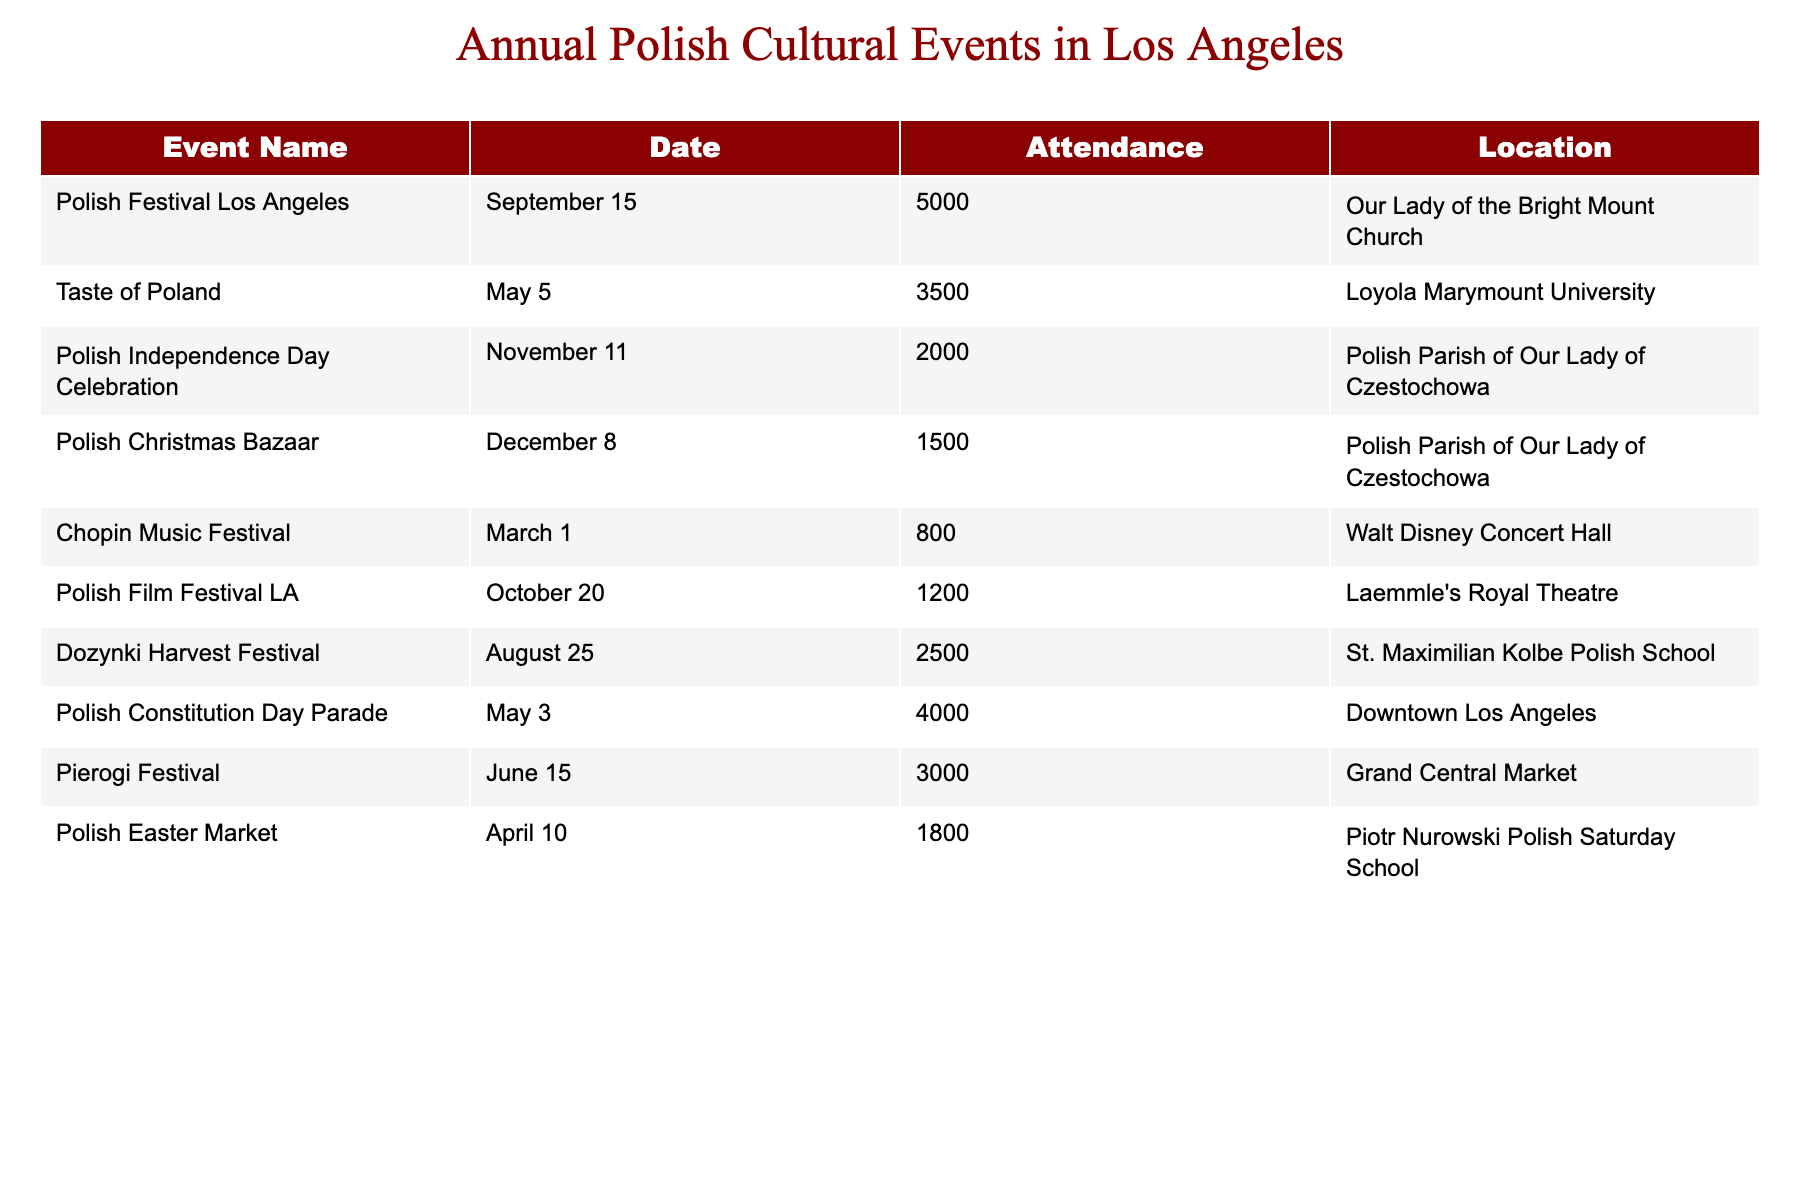What is the highest attendance figure recorded for any event? The highest attendance figure can be found by comparing the values in the Attendance column. Upon reviewing, the attendance for the Polish Festival Los Angeles is 5000, which is greater than all other provided figures.
Answer: 5000 Which event took place in December? The only event listed in December is the Polish Christmas Bazaar, which is shown in the table with its corresponding date.
Answer: Polish Christmas Bazaar What is the average attendance of the festivals held in May? The festivals held in May are the Taste of Poland with 3500 attendees and the Polish Constitution Day Parade with 4000. Adding these figures gives 3500 + 4000 = 7500. To find the average, we divide by the number of events (2): 7500 / 2 = 3750.
Answer: 3750 How many events had an attendance of 3000 or more? We can count the events listed with attendance figures of 3000 or more. These are the Polish Festival Los Angeles (5000), Taste of Poland (3500), Polish Constitution Day Parade (4000), Dozynki Harvest Festival (2500), and Pierogi Festival (3000). A careful count shows there are four events meeting this criterion.
Answer: 4 Was there an event with an attendance of exactly 1800? Upon review of the attendance figures in the table, we find that the Polish Easter Market has an attendance of exactly 1800.
Answer: Yes What is the total attendance across all events listed? To find the total attendance, we sum the attendance numbers from each event: 5000 + 3500 + 2000 + 1500 + 800 + 1200 + 2500 + 4000 + 3000 + 1800 = 19,300.
Answer: 19300 Which event had the least attendance and what was that number? By comparing all attendance figures, the Chopin Music Festival has the least attendance of 800. Thus, it is the event with the lowest turnout in the table.
Answer: 800 How many events occurred in the second half of the year (July to December)? The events occurring in the second half of the year from the table are the Polish Independence Day Celebration (November 11), Polish Christmas Bazaar (December 8), Polish Film Festival LA (October 20), and Pierogi Festival (June 15). A count shows there are four such events.
Answer: 4 Did more people attend the Polish Independence Day Celebration or the Polish Christmas Bazaar? The attendance for the Polish Independence Day Celebration is 2000 while the attendance for the Polish Christmas Bazaar is 1500. Comparing these two figures shows that 2000 is greater than 1500, indicating more people attended the Independence Day event.
Answer: Polish Independence Day Celebration What is the difference in attendance between the Polish Festival Los Angeles and the Dozynki Harvest Festival? The attendance for the Polish Festival Los Angeles is 5000 and for the Dozynki Harvest Festival, it is 2500. The difference can be calculated by subtracting: 5000 - 2500 = 2500.
Answer: 2500 